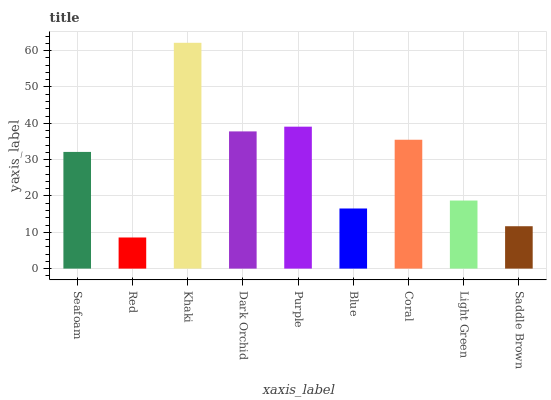Is Red the minimum?
Answer yes or no. Yes. Is Khaki the maximum?
Answer yes or no. Yes. Is Khaki the minimum?
Answer yes or no. No. Is Red the maximum?
Answer yes or no. No. Is Khaki greater than Red?
Answer yes or no. Yes. Is Red less than Khaki?
Answer yes or no. Yes. Is Red greater than Khaki?
Answer yes or no. No. Is Khaki less than Red?
Answer yes or no. No. Is Seafoam the high median?
Answer yes or no. Yes. Is Seafoam the low median?
Answer yes or no. Yes. Is Coral the high median?
Answer yes or no. No. Is Dark Orchid the low median?
Answer yes or no. No. 